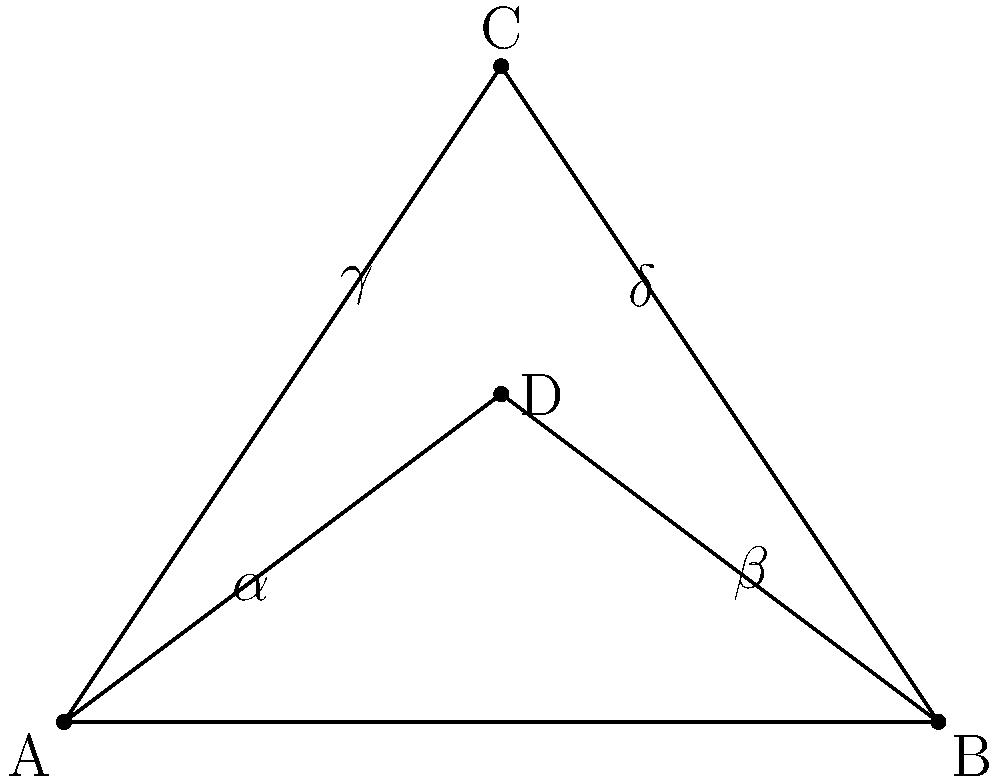In proper squat form, the angle between the upper leg and the lower leg changes throughout the movement. Consider the diagram representing two stages of a squat: the starting position (triangle ABC) and the bottom position (triangle ABD). If $\angle CAB = \alpha$, $\angle CBA = \beta$, $\angle ACD = \gamma$, and $\angle BCD = \delta$, which of the following statements is true about the congruence of these angles? Let's analyze this step-by-step:

1) In triangle ABC:
   - $\angle CAB = \alpha$
   - $\angle CBA = \beta$
   - $\angle ACB = \gamma + \delta$ (as C is above D)

2) In triangle ABD:
   - $\angle DAB = \alpha$ (same as $\angle CAB$)
   - $\angle DBA = \beta$ (same as $\angle CBA$)
   - $\angle ADB = 180^\circ - (\alpha + \beta)$ (sum of angles in a triangle is 180°)

3) In triangle ABC, we know that:
   $\alpha + \beta + (\gamma + \delta) = 180^\circ$ (sum of angles in a triangle)

4) Comparing the angles in triangles ABC and ABD:
   - $\angle CAB \cong \angle DAB$ (both are $\alpha$)
   - $\angle CBA \cong \angle DBA$ (both are $\beta$)
   - $\angle ACB = \gamma + \delta = 180^\circ - (\alpha + \beta) = \angle ADB$

5) Therefore, all corresponding angles in triangles ABC and ABD are congruent.

6) By the Angle-Angle (AA) similarity criterion, if two pairs of corresponding angles in two triangles are congruent, the triangles are similar.

7) In this case, all three pairs of corresponding angles are congruent, which means triangles ABC and ABD are not only similar but also congruent.
Answer: Triangles ABC and ABD are congruent. 